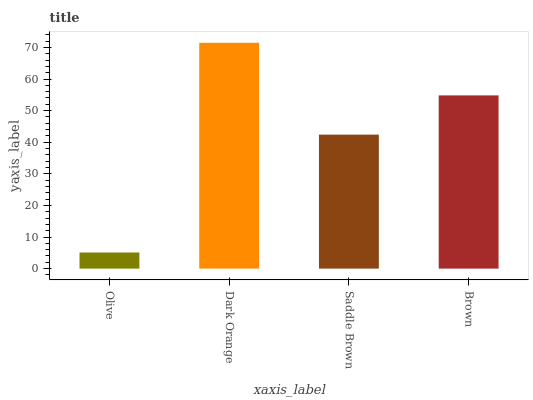Is Olive the minimum?
Answer yes or no. Yes. Is Dark Orange the maximum?
Answer yes or no. Yes. Is Saddle Brown the minimum?
Answer yes or no. No. Is Saddle Brown the maximum?
Answer yes or no. No. Is Dark Orange greater than Saddle Brown?
Answer yes or no. Yes. Is Saddle Brown less than Dark Orange?
Answer yes or no. Yes. Is Saddle Brown greater than Dark Orange?
Answer yes or no. No. Is Dark Orange less than Saddle Brown?
Answer yes or no. No. Is Brown the high median?
Answer yes or no. Yes. Is Saddle Brown the low median?
Answer yes or no. Yes. Is Olive the high median?
Answer yes or no. No. Is Olive the low median?
Answer yes or no. No. 